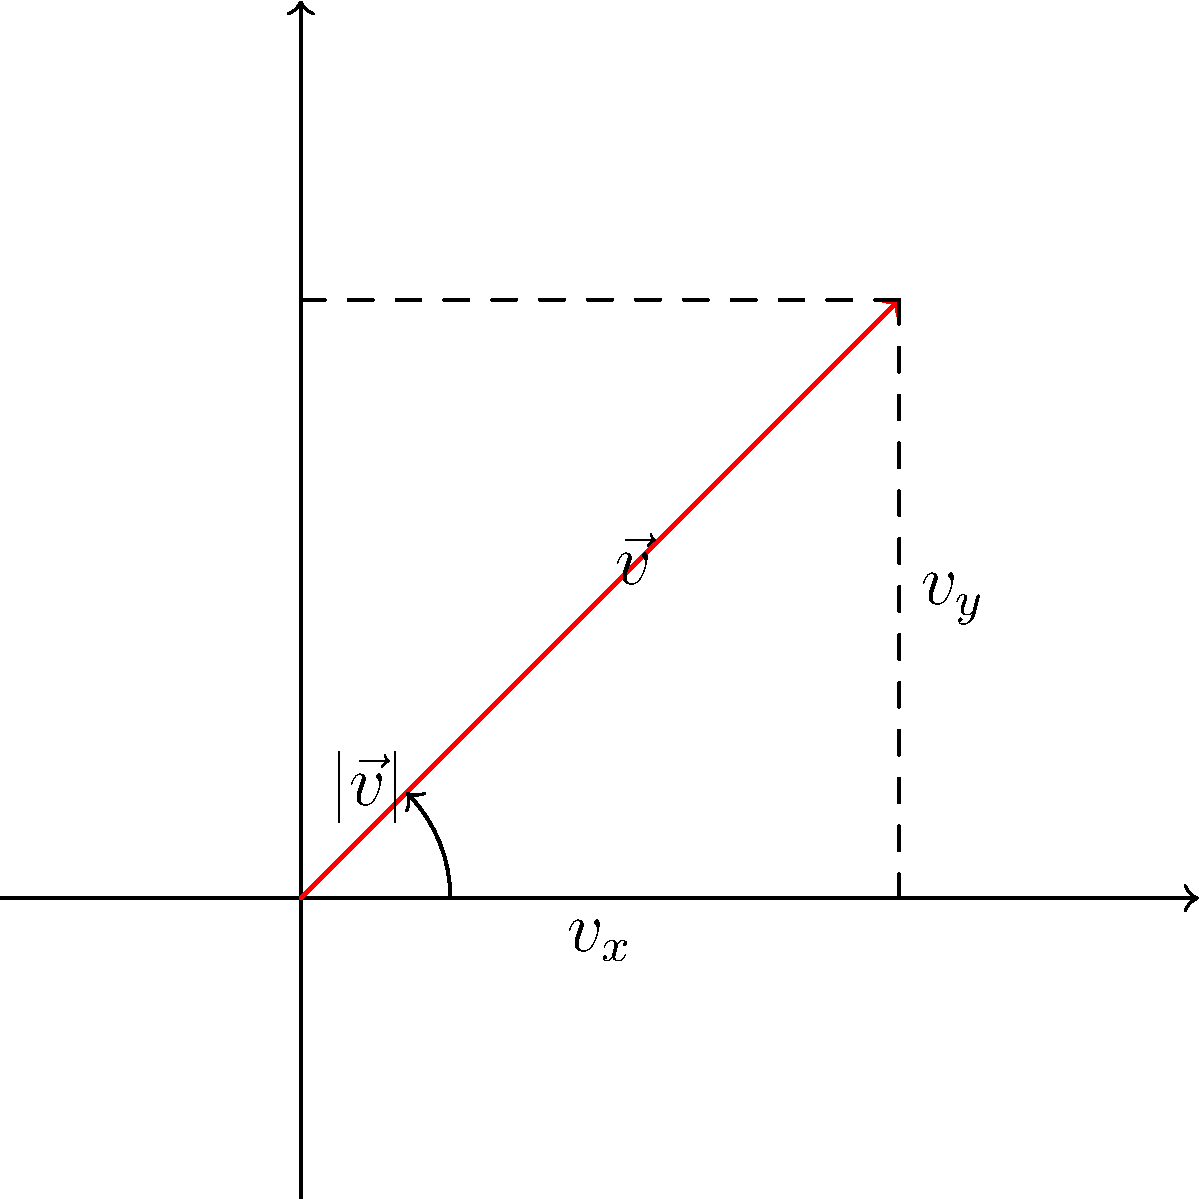In your minimalist game, an entity moves with velocity vector $\vec{v} = (2, 2)$. To ensure consistent speed regardless of direction, you need to normalize this vector. What is the normalized vector $\vec{u}$? To normalize a vector, we follow these steps:

1. Calculate the magnitude of the vector:
   $|\vec{v}| = \sqrt{v_x^2 + v_y^2} = \sqrt{2^2 + 2^2} = \sqrt{8} = 2\sqrt{2}$

2. Divide each component by the magnitude:
   $\vec{u} = \frac{\vec{v}}{|\vec{v}|} = (\frac{v_x}{|\vec{v}|}, \frac{v_y}{|\vec{v}|})$

3. Substitute the values:
   $\vec{u} = (\frac{2}{2\sqrt{2}}, \frac{2}{2\sqrt{2}})$

4. Simplify:
   $\vec{u} = (\frac{1}{\sqrt{2}}, \frac{1}{\sqrt{2}})$

The normalized vector $\vec{u}$ has a magnitude of 1, ensuring consistent speed regardless of direction.
Answer: $(\frac{1}{\sqrt{2}}, \frac{1}{\sqrt{2}})$ 